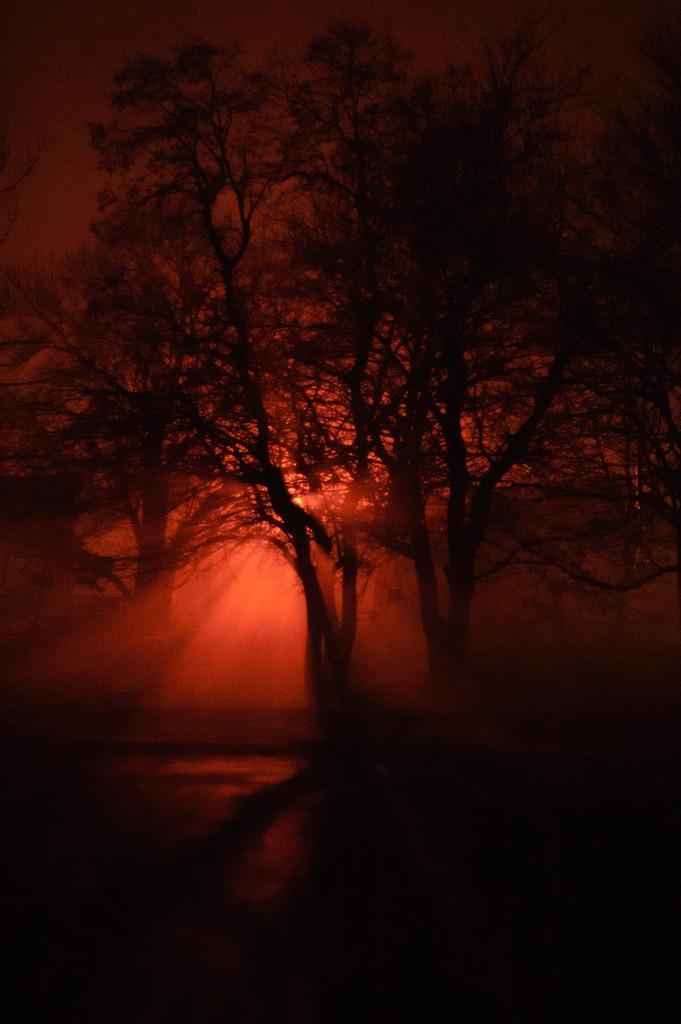Please provide a concise description of this image. In the picture I can see trees and sun rays. 